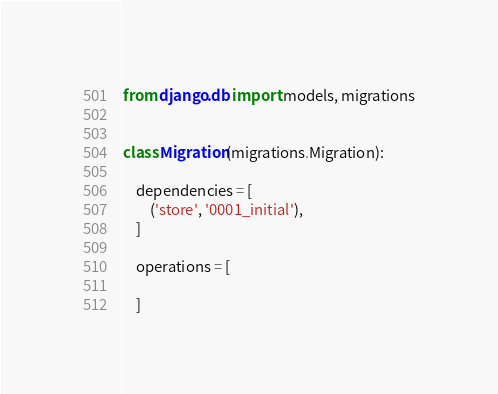Convert code to text. <code><loc_0><loc_0><loc_500><loc_500><_Python_>
from django.db import models, migrations


class Migration(migrations.Migration):

    dependencies = [
        ('store', '0001_initial'),
    ]

    operations = [

    ]
</code> 